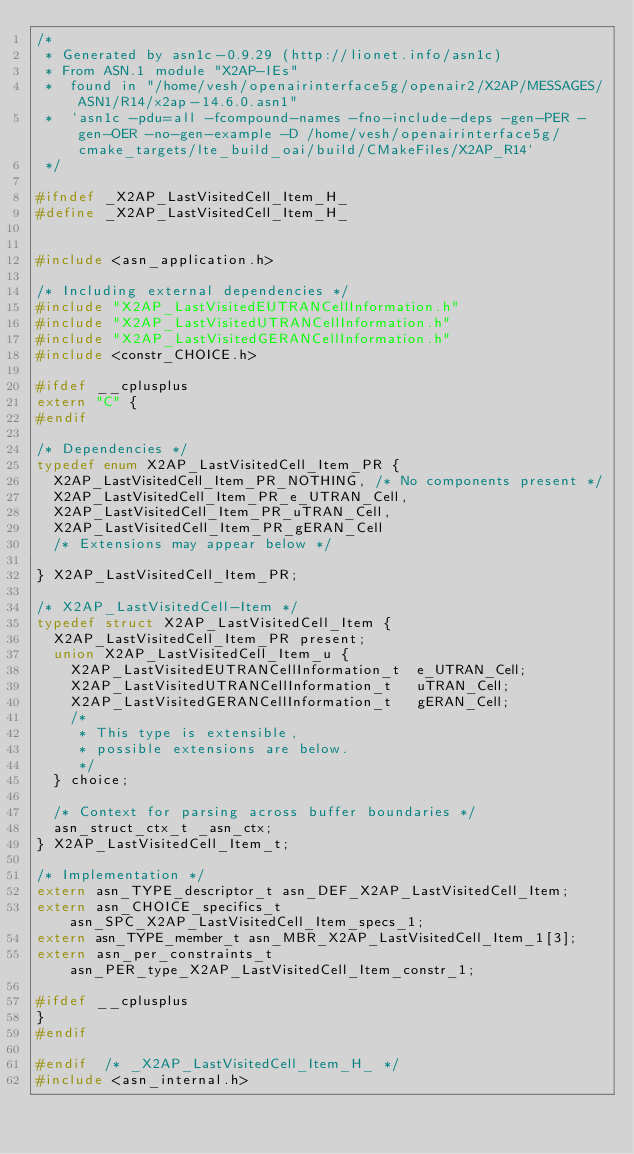Convert code to text. <code><loc_0><loc_0><loc_500><loc_500><_C_>/*
 * Generated by asn1c-0.9.29 (http://lionet.info/asn1c)
 * From ASN.1 module "X2AP-IEs"
 * 	found in "/home/vesh/openairinterface5g/openair2/X2AP/MESSAGES/ASN1/R14/x2ap-14.6.0.asn1"
 * 	`asn1c -pdu=all -fcompound-names -fno-include-deps -gen-PER -gen-OER -no-gen-example -D /home/vesh/openairinterface5g/cmake_targets/lte_build_oai/build/CMakeFiles/X2AP_R14`
 */

#ifndef	_X2AP_LastVisitedCell_Item_H_
#define	_X2AP_LastVisitedCell_Item_H_


#include <asn_application.h>

/* Including external dependencies */
#include "X2AP_LastVisitedEUTRANCellInformation.h"
#include "X2AP_LastVisitedUTRANCellInformation.h"
#include "X2AP_LastVisitedGERANCellInformation.h"
#include <constr_CHOICE.h>

#ifdef __cplusplus
extern "C" {
#endif

/* Dependencies */
typedef enum X2AP_LastVisitedCell_Item_PR {
	X2AP_LastVisitedCell_Item_PR_NOTHING,	/* No components present */
	X2AP_LastVisitedCell_Item_PR_e_UTRAN_Cell,
	X2AP_LastVisitedCell_Item_PR_uTRAN_Cell,
	X2AP_LastVisitedCell_Item_PR_gERAN_Cell
	/* Extensions may appear below */
	
} X2AP_LastVisitedCell_Item_PR;

/* X2AP_LastVisitedCell-Item */
typedef struct X2AP_LastVisitedCell_Item {
	X2AP_LastVisitedCell_Item_PR present;
	union X2AP_LastVisitedCell_Item_u {
		X2AP_LastVisitedEUTRANCellInformation_t	 e_UTRAN_Cell;
		X2AP_LastVisitedUTRANCellInformation_t	 uTRAN_Cell;
		X2AP_LastVisitedGERANCellInformation_t	 gERAN_Cell;
		/*
		 * This type is extensible,
		 * possible extensions are below.
		 */
	} choice;
	
	/* Context for parsing across buffer boundaries */
	asn_struct_ctx_t _asn_ctx;
} X2AP_LastVisitedCell_Item_t;

/* Implementation */
extern asn_TYPE_descriptor_t asn_DEF_X2AP_LastVisitedCell_Item;
extern asn_CHOICE_specifics_t asn_SPC_X2AP_LastVisitedCell_Item_specs_1;
extern asn_TYPE_member_t asn_MBR_X2AP_LastVisitedCell_Item_1[3];
extern asn_per_constraints_t asn_PER_type_X2AP_LastVisitedCell_Item_constr_1;

#ifdef __cplusplus
}
#endif

#endif	/* _X2AP_LastVisitedCell_Item_H_ */
#include <asn_internal.h>
</code> 